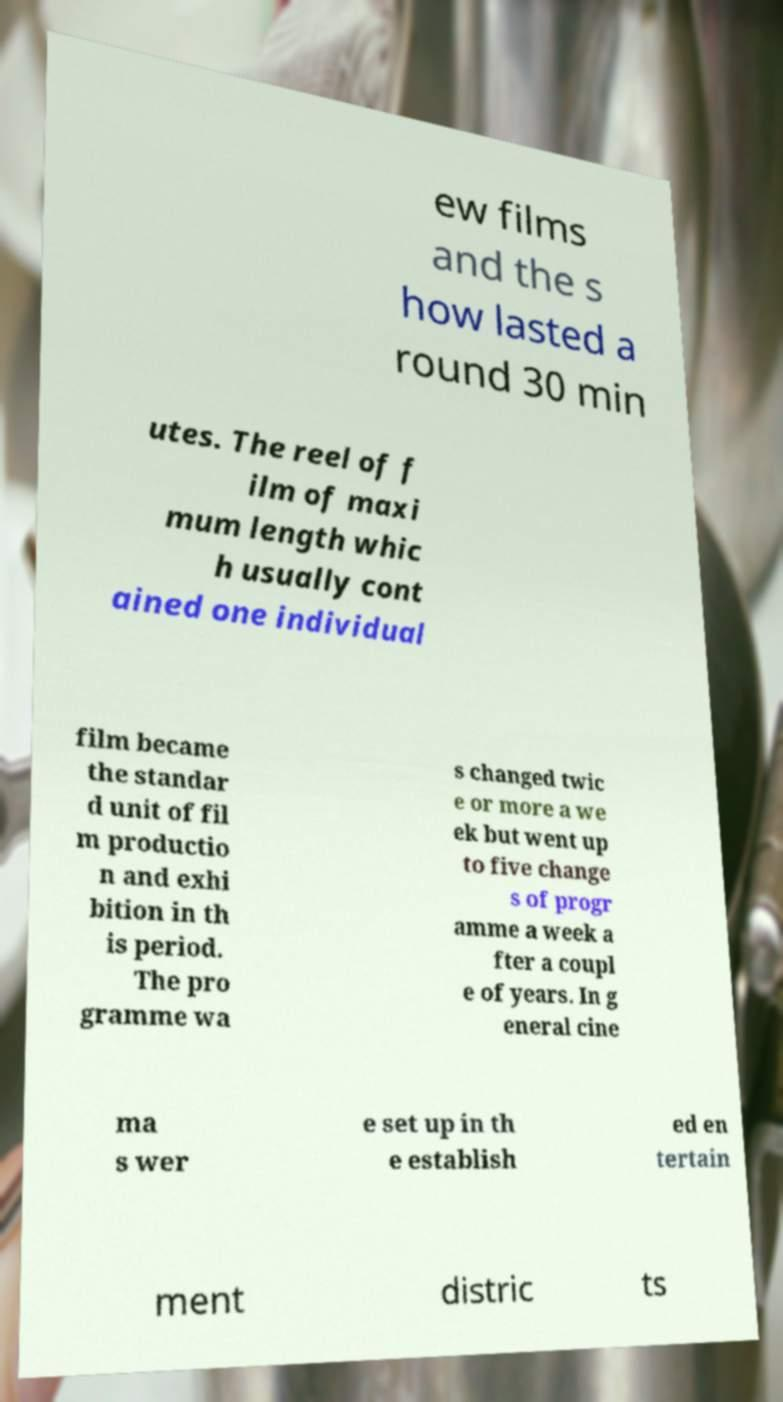Could you extract and type out the text from this image? ew films and the s how lasted a round 30 min utes. The reel of f ilm of maxi mum length whic h usually cont ained one individual film became the standar d unit of fil m productio n and exhi bition in th is period. The pro gramme wa s changed twic e or more a we ek but went up to five change s of progr amme a week a fter a coupl e of years. In g eneral cine ma s wer e set up in th e establish ed en tertain ment distric ts 